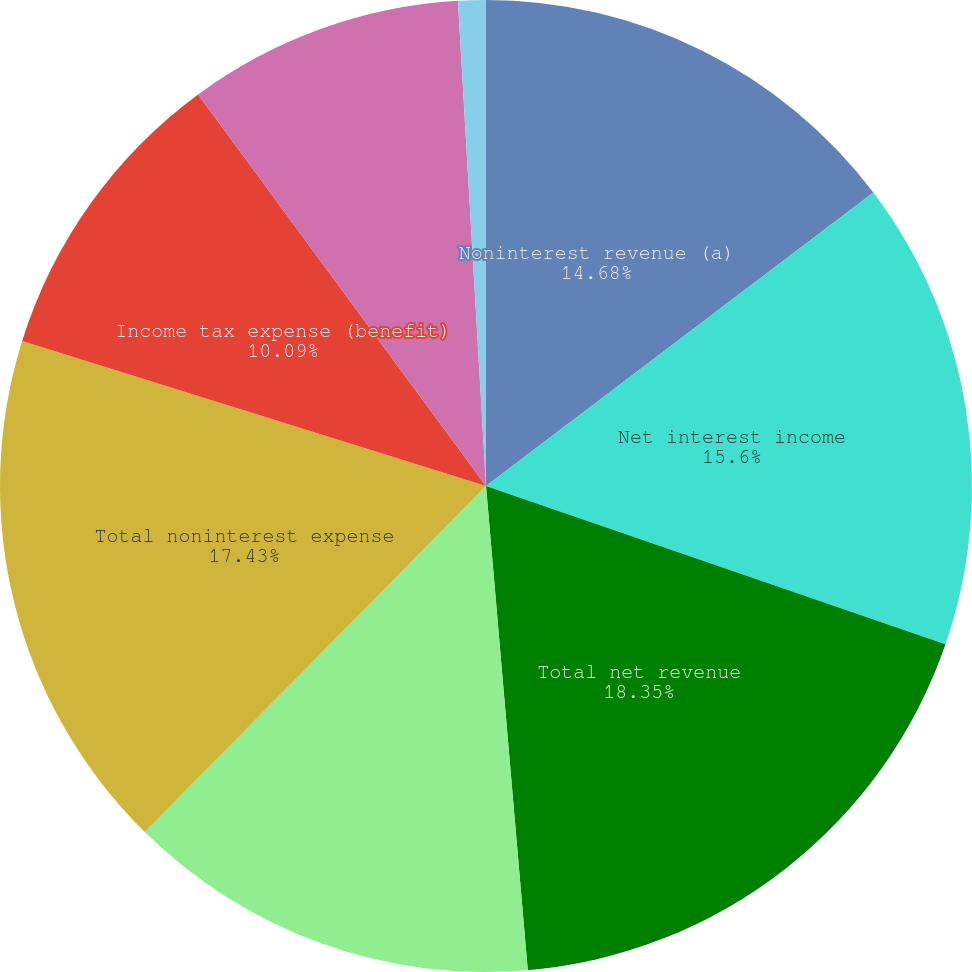Convert chart to OTSL. <chart><loc_0><loc_0><loc_500><loc_500><pie_chart><fcel>Noninterest revenue (a)<fcel>Net interest income<fcel>Total net revenue<fcel>Provision for credit losses<fcel>Total noninterest expense<fcel>Income tax expense (benefit)<fcel>Income (loss) before<fcel>Net income<fcel>Cash dividends declared per<nl><fcel>14.68%<fcel>15.6%<fcel>18.35%<fcel>13.76%<fcel>17.43%<fcel>10.09%<fcel>0.0%<fcel>9.17%<fcel>0.92%<nl></chart> 